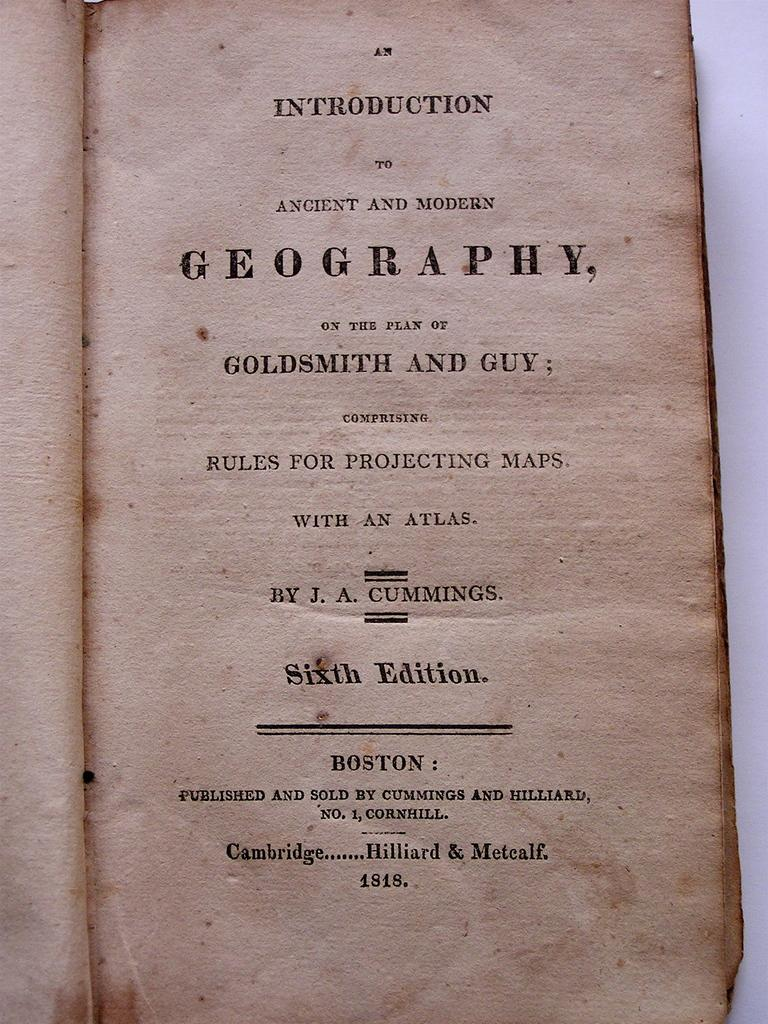<image>
Offer a succinct explanation of the picture presented. An older opened book of the sixth edition by J. A. Cummings. 